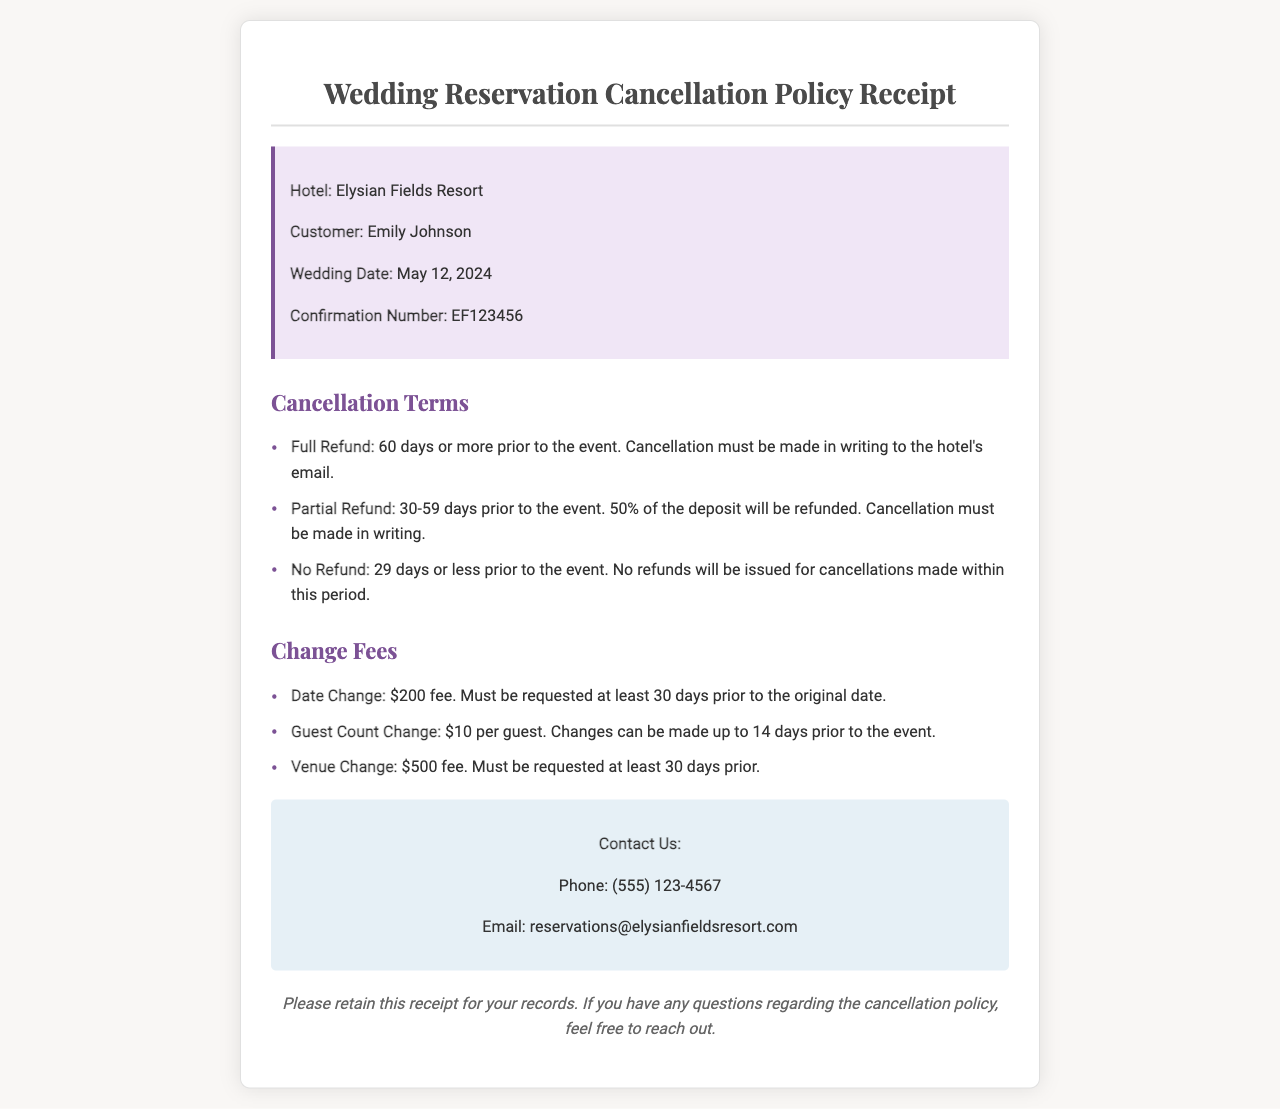What is the hotel's name? The hotel's name is mentioned in the customer details section of the document.
Answer: Elysian Fields Resort What is the wedding date? The wedding date is provided in the customer details section.
Answer: May 12, 2024 What is the confirmation number? The confirmation number is given in the customer details section.
Answer: EF123456 What is the refund policy for cancellations made 30-59 days prior to the event? The refund policy outlines the amount refunded for cancellations made within this timeframe.
Answer: 50% of the deposit What is the fee for changing the event date? The change fees provide the specific amount for changing the event date.
Answer: $200 How many days in advance must a date change be requested to avoid fees? The requirements for requesting a date change are specified in the change fees section.
Answer: 30 days What happens if a cancellation is made 29 days or less before the event? The cancellation policy states the outcome for cancellations made within this timeframe.
Answer: No refunds will be issued What is the charge per guest for changes to the guest count? The document specifies the per-guest fee for changes in the guest count.
Answer: $10 per guest Who should be contacted for questions regarding the cancellation policy? The contact information section provides details on who to reach out to for inquiries.
Answer: reservations@elysianfieldsresort.com 